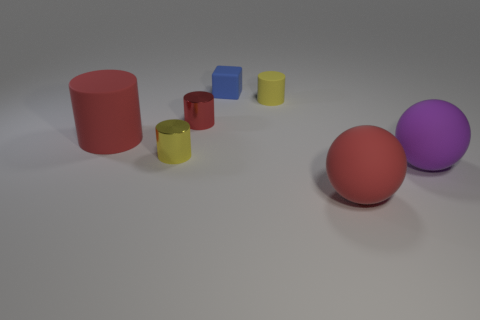How many other things are the same shape as the blue matte thing?
Keep it short and to the point. 0. Is the shape of the rubber thing that is left of the block the same as  the purple thing?
Give a very brief answer. No. Are there any red cylinders behind the yellow matte cylinder?
Offer a very short reply. No. What number of small things are blue matte objects or red balls?
Offer a terse response. 1. Are the blue cube and the big purple sphere made of the same material?
Offer a terse response. Yes. There is another cylinder that is the same color as the small rubber cylinder; what is its size?
Ensure brevity in your answer.  Small. Is there a small thing that has the same color as the rubber block?
Your answer should be compact. No. There is a cube that is the same material as the big red cylinder; what size is it?
Keep it short and to the point. Small. There is a purple matte object to the right of the object behind the tiny yellow cylinder that is behind the tiny red shiny cylinder; what is its shape?
Offer a terse response. Sphere. There is a yellow rubber object that is the same shape as the red metal thing; what is its size?
Keep it short and to the point. Small. 